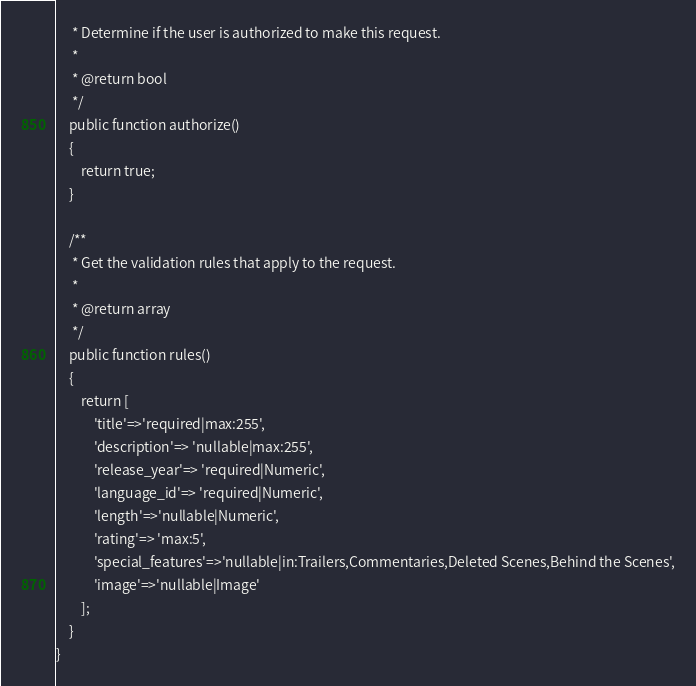Convert code to text. <code><loc_0><loc_0><loc_500><loc_500><_PHP_>     * Determine if the user is authorized to make this request.
     *
     * @return bool
     */
    public function authorize()
    {
        return true;
    }

    /**
     * Get the validation rules that apply to the request.
     *
     * @return array
     */
    public function rules()
    {
        return [
            'title'=>'required|max:255',
            'description'=> 'nullable|max:255',
            'release_year'=> 'required|Numeric',
            'language_id'=> 'required|Numeric',
            'length'=>'nullable|Numeric',
            'rating'=> 'max:5',
            'special_features'=>'nullable|in:Trailers,Commentaries,Deleted Scenes,Behind the Scenes',
            'image'=>'nullable|Image'
        ];
    }
}
</code> 